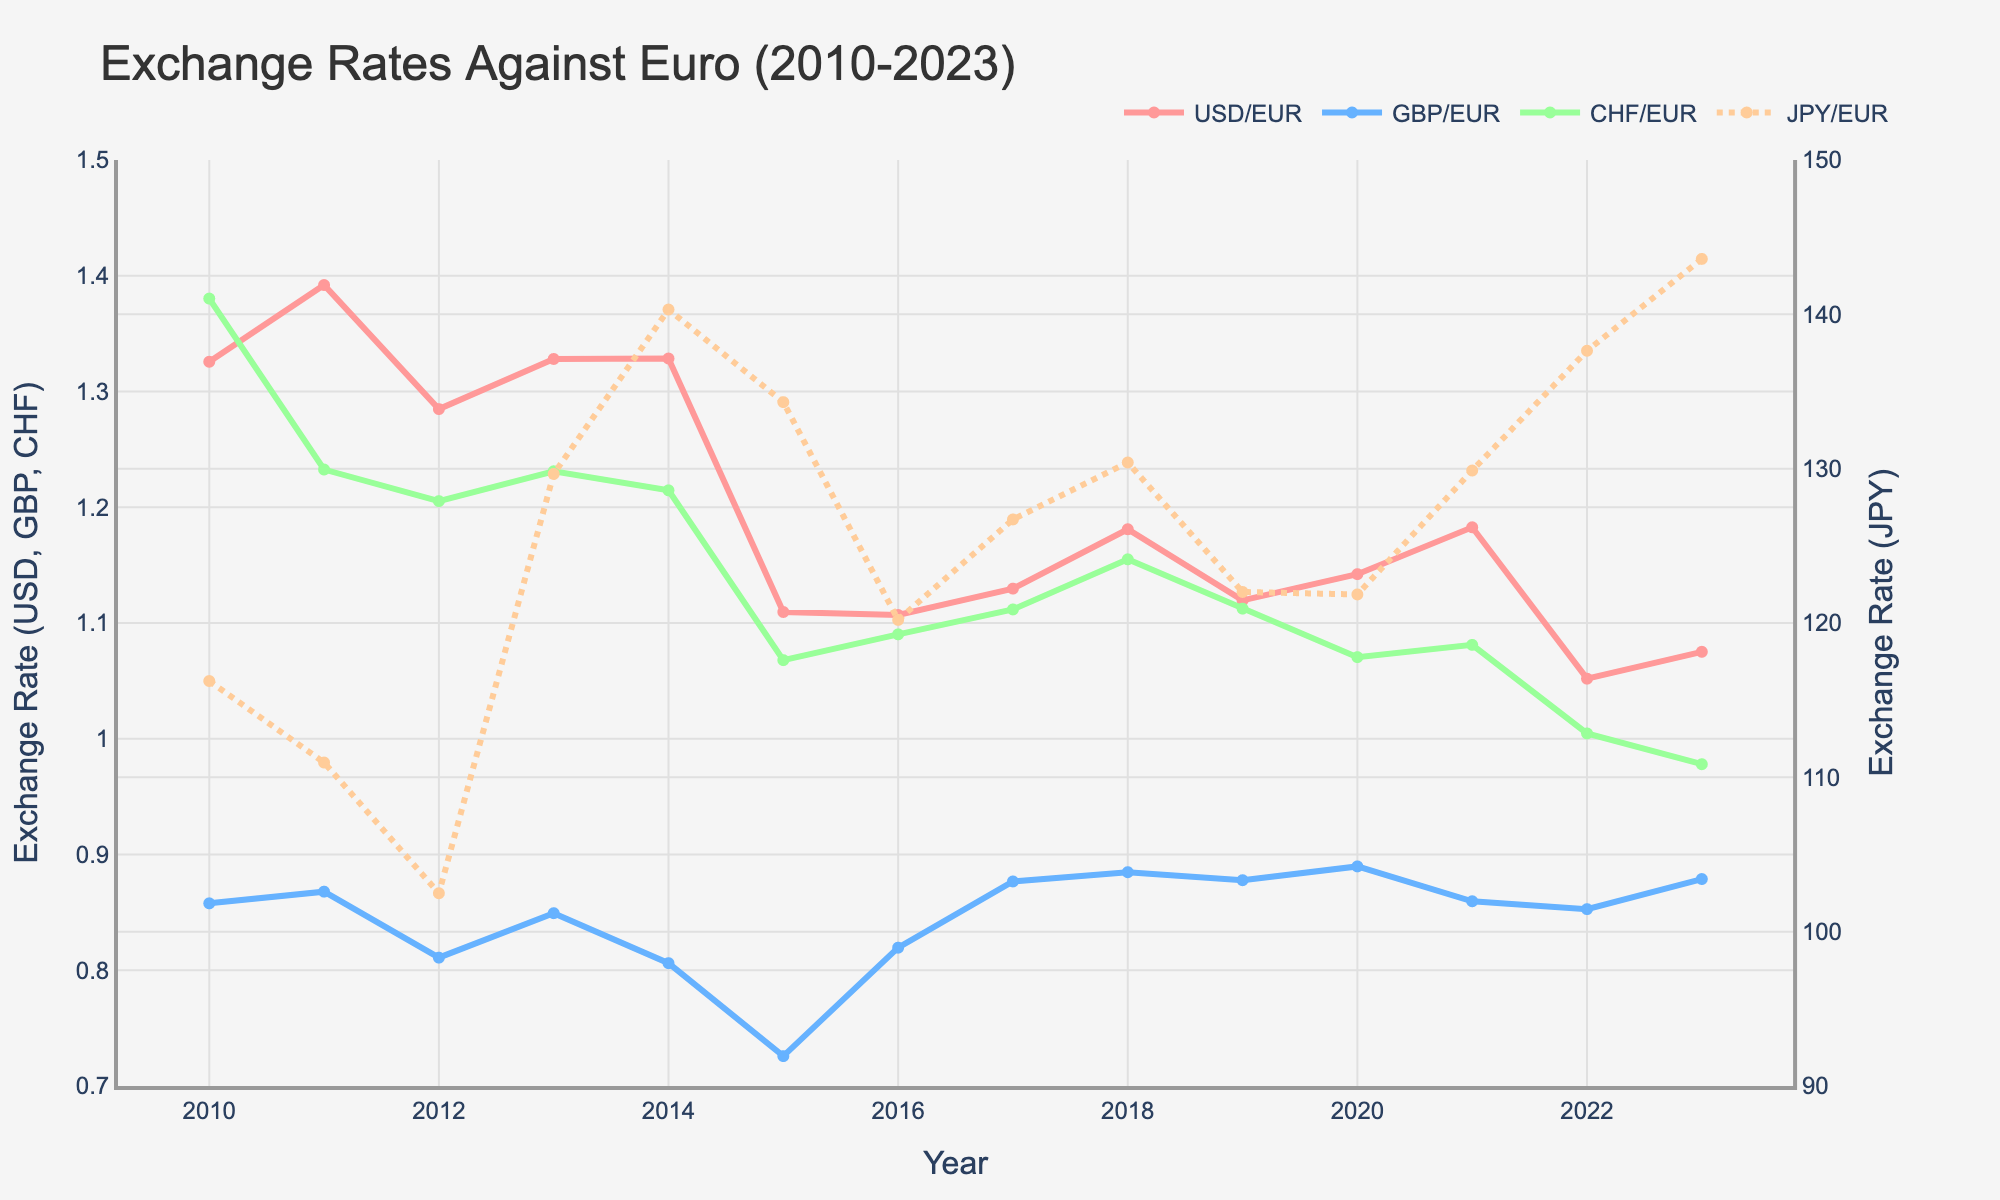What's the trend of the USD/EUR exchange rate from 2010 to 2023? To identify the trend, observe the line representing USD/EUR from 2010 to 2023. The line fluctuates but generally shows a decrease from 2010, a dip around 2015, and slight recovery in later years.
Answer: Decreasing trend Which year had the highest GBP/EUR exchange rate? Look for the peak point on the line representing GBP/EUR. The maximum value appears around 2018.
Answer: 2018 How did the JPY/EUR exchange rate change from 2010 to 2023? Examine the dotted line representing JPY/EUR over the years. It starts around 116 in 2010, peaks and dips, finally ending at the highest value around 144 in 2023.
Answer: Increased What is the approximate difference in the USD/EUR exchange rate between 2010 and 2023? Identify the values for USD/EUR in 2010 (about 1.33) and 2023 (about 1.08). Subtract the 2023 value from the 2010 value.
Answer: 0.25 In which year did the CHF/EUR exchange rate drop below 1.0? Observe the line representing CHF/EUR and identify when it dips below 1.0. This occurs around 2022.
Answer: 2022 Compare the average exchange rates of USD/EUR and CHF/EUR from 2010 to 2023. Sum the values for USD/EUR and CHF/EUR over the years and divide by the number of years (14). USD/EUR average is around 1.22 and CHF/EUR average is around 1.15. Compare these averages.
Answer: USD/EUR is higher Which exchange rate shows the most volatility over the years? Assess the lines for USD/EUR, GBP/EUR, CHF/EUR, and JPY/EUR. The JPY/EUR line has the most fluctuations indicating highest volatility.
Answer: JPY/EUR What was the USD/EUR exchange rate trend during the European debt crisis period (2010-2012)? Focus on the segment of the USD/EUR line from 2010 to 2012. The line oscillates but shows a general decline from 1.33 to around 1.28.
Answer: Decreasing Which currency had the most stable exchange rate against the Euro from 2010 to 2023? Assess the lines representing USD/EUR, GBP/EUR, CHF/EUR, and JPY/EUR. The CHF/EUR line shows the least variation indicating the most stability.
Answer: CHF/EUR Identify the year with the lowest JPY/EUR exchange rate and provide its value. Look for the lowest point on the JPY/EUR dotted line throughout the chart. It occurs around 2012, with a value close to 102.
Answer: 2012, 102 